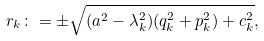Convert formula to latex. <formula><loc_0><loc_0><loc_500><loc_500>r _ { k } \colon = \pm \sqrt { ( a ^ { 2 } - \lambda _ { k } ^ { 2 } ) ( q _ { k } ^ { 2 } + p _ { k } ^ { 2 } ) + c _ { k } ^ { 2 } } ,</formula> 